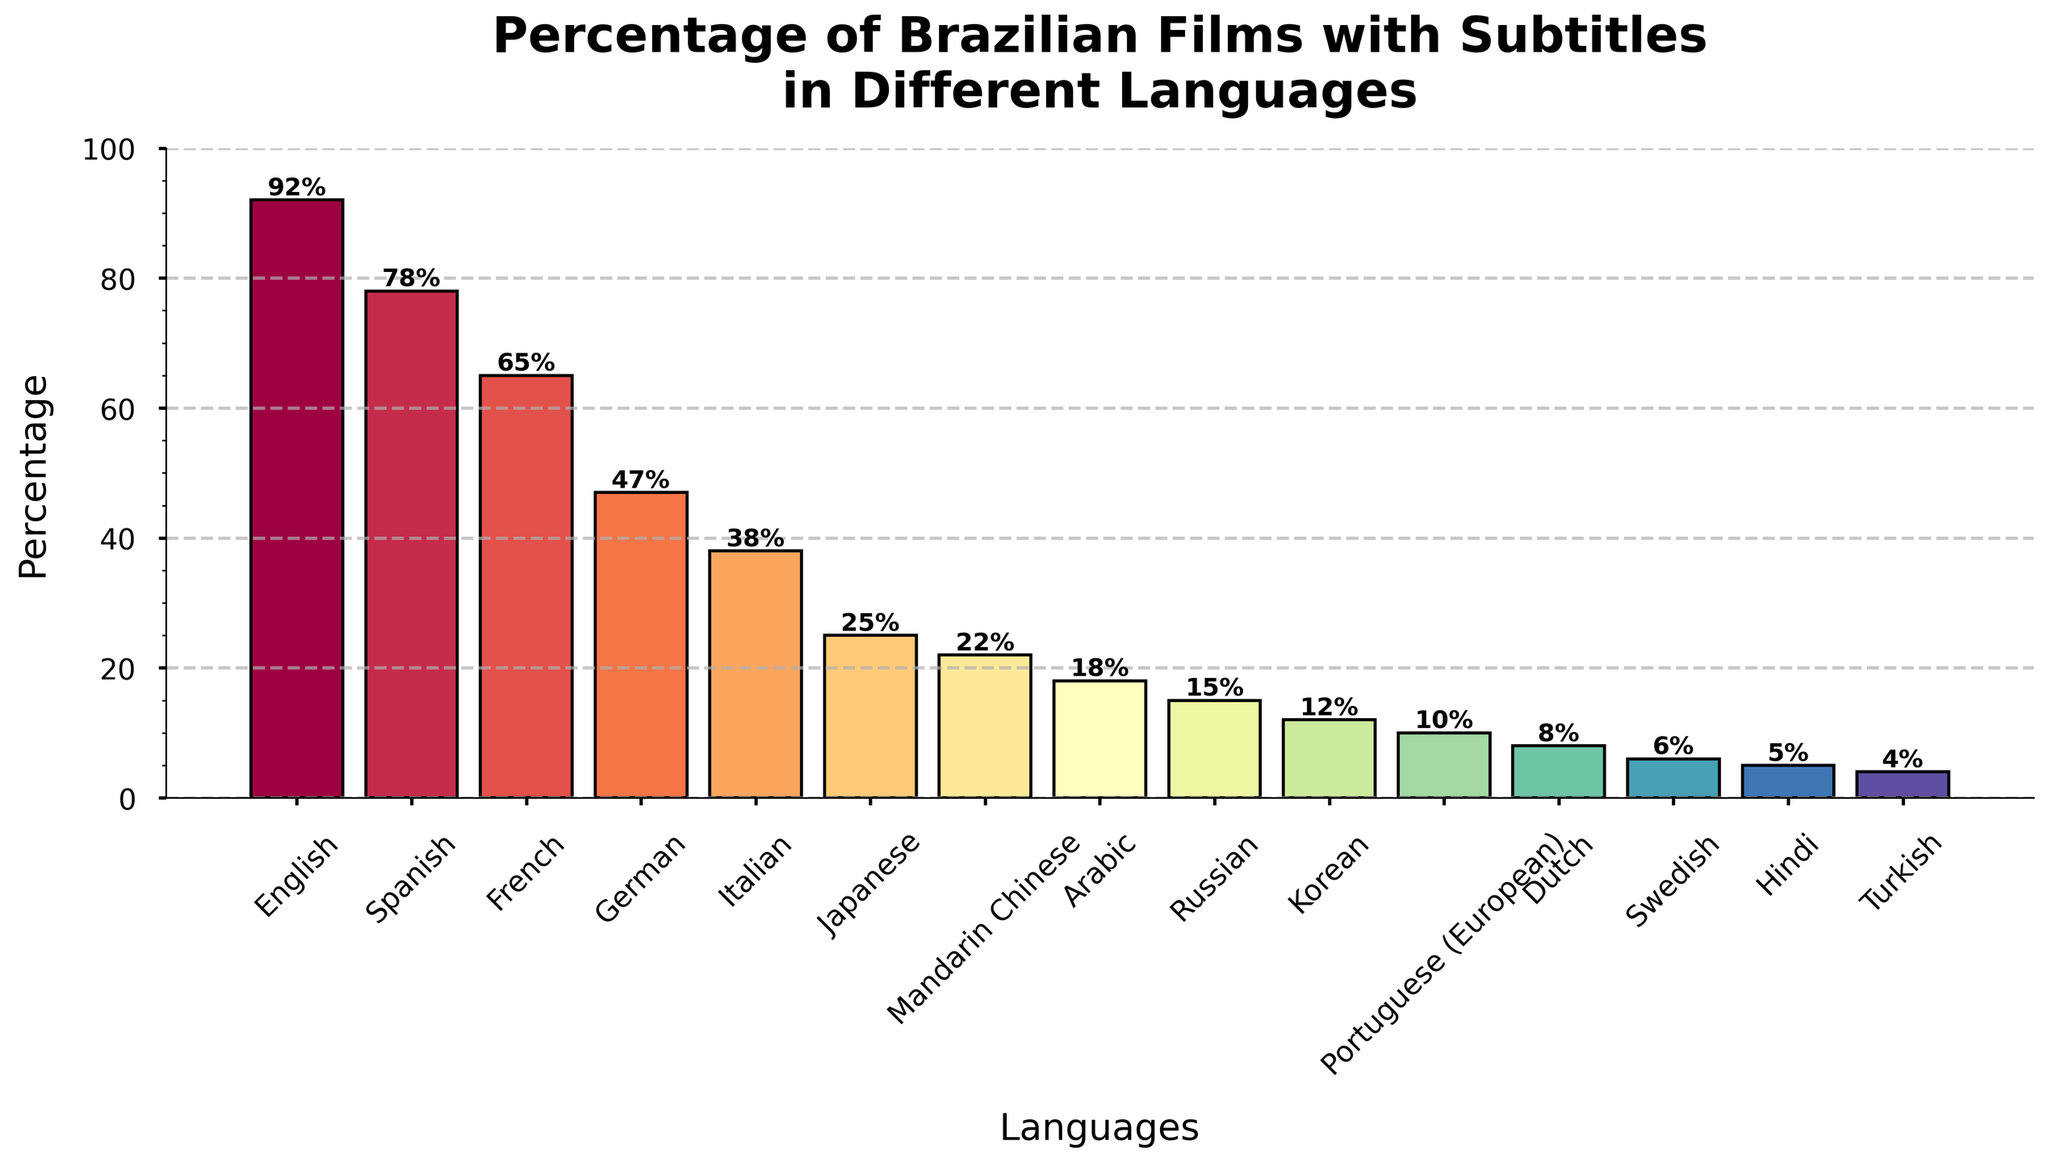What's the percentage of Brazilian films with English subtitles? To find the percentage, locate the bar corresponding to 'English'. The height of this bar represents the percentage.
Answer: 92% Which language has the lowest percentage of Brazilian films with subtitles? Identify the shortest bar in the figure. The label of this bar indicates the language with the lowest percentage.
Answer: Turkish Which languages have more than 50% of Brazilian films with subtitles? Look at all the bars and identify those that extend above the 50% mark.
Answer: English, Spanish, French What's the difference in percentage between Brazilian films with English subtitles and French subtitles? Find the heights of the bars for 'English' and 'French'. Subtract the percentage of French from English: 92% - 65% = 27%.
Answer: 27% How many languages have a percentage of Brazilian films with subtitles below 20%? Count the number of bars that do not extend above the 20% mark.
Answer: 6 Do more Brazilian films have Japanese or Italian subtitles? Compare the heights of the bars for 'Japanese' and 'Italian'. The taller bar represents the higher percentage.
Answer: Italian Which language has the closest percentage to 50% of Brazilian films with subtitles? Identify the bar whose height is nearest to the 50% mark.
Answer: German What is the combined percentage of Brazilian films with German and Arabic subtitles? Find the heights of the bars for 'German' and 'Arabic' and add them: 47% + 18% = 65%.
Answer: 65% Which language has subtitles in less than 10% of Brazilian films? Identify the bars with a height less than the 10% mark and note the corresponding language.
Answer: Hindi, Turkish Between Mandarin Chinese and Korean, which has a higher percentage of Brazilian films with subtitles? Compare the heights of the bars for 'Mandarin Chinese' and 'Korean'. The taller bar indicates the higher percentage.
Answer: Mandarin Chinese 